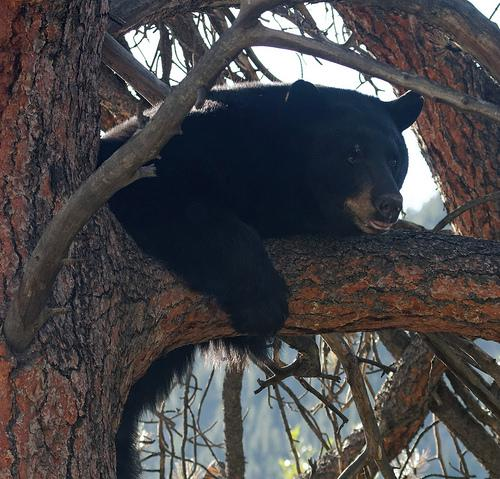Question: who is in the tree?
Choices:
A. The bear.
B. The bird.
C. The squirrel.
D. The bee.
Answer with the letter. Answer: A Question: what color is the bear?
Choices:
A. Black.
B. Brown.
C. White.
D. Tan.
Answer with the letter. Answer: A Question: when is this?
Choices:
A. Nighttime.
B. Daytime.
C. Morning time.
D. Noon.
Answer with the letter. Answer: B Question: what color is the bark?
Choices:
A. Green.
B. Brown.
C. Tan.
D. Orange.
Answer with the letter. Answer: B Question: where is this scene?
Choices:
A. Indoors.
B. In a bus depot.
C. In space.
D. In nature.
Answer with the letter. Answer: D 